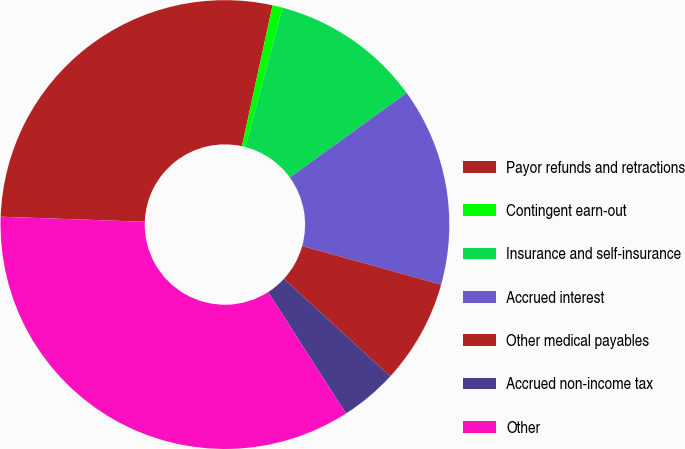Convert chart to OTSL. <chart><loc_0><loc_0><loc_500><loc_500><pie_chart><fcel>Payor refunds and retractions<fcel>Contingent earn-out<fcel>Insurance and self-insurance<fcel>Accrued interest<fcel>Other medical payables<fcel>Accrued non-income tax<fcel>Other<nl><fcel>27.85%<fcel>0.72%<fcel>10.9%<fcel>14.29%<fcel>7.51%<fcel>4.11%<fcel>34.63%<nl></chart> 